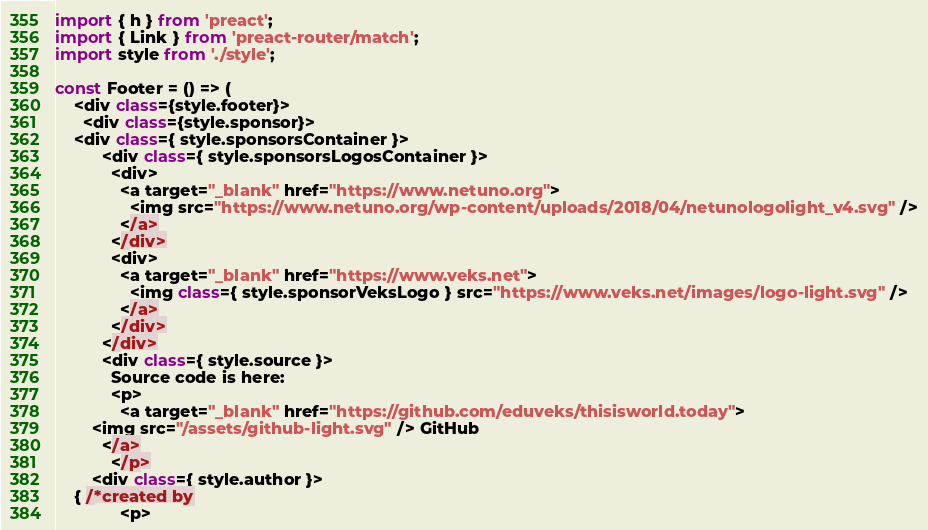<code> <loc_0><loc_0><loc_500><loc_500><_JavaScript_>import { h } from 'preact';
import { Link } from 'preact-router/match';
import style from './style';

const Footer = () => (
    <div class={style.footer}>
      <div class={style.sponsor}>
	<div class={ style.sponsorsContainer }>
          <div class={ style.sponsorsLogosContainer }>
            <div>
              <a target="_blank" href="https://www.netuno.org">
                <img src="https://www.netuno.org/wp-content/uploads/2018/04/netunologolight_v4.svg" />
              </a>
            </div>
            <div>
              <a target="_blank" href="https://www.veks.net">
                <img class={ style.sponsorVeksLogo } src="https://www.veks.net/images/logo-light.svg" />
              </a>
            </div>
          </div>
          <div class={ style.source }>
            Source code is here:
            <p>
              <a target="_blank" href="https://github.com/eduveks/thisisworld.today">
		<img src="/assets/github-light.svg" /> GitHub
	      </a>
            </p>
	    <div class={ style.author }>
	{ /*created by
              <p></code> 